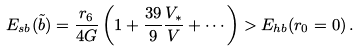Convert formula to latex. <formula><loc_0><loc_0><loc_500><loc_500>E _ { s b } ( \tilde { b } ) = \frac { r _ { 6 } } { 4 G } \left ( 1 + \frac { 3 9 } { 9 } \frac { V _ { * } } { V } + \cdots \right ) > E _ { h b } ( r _ { 0 } = 0 ) \, .</formula> 